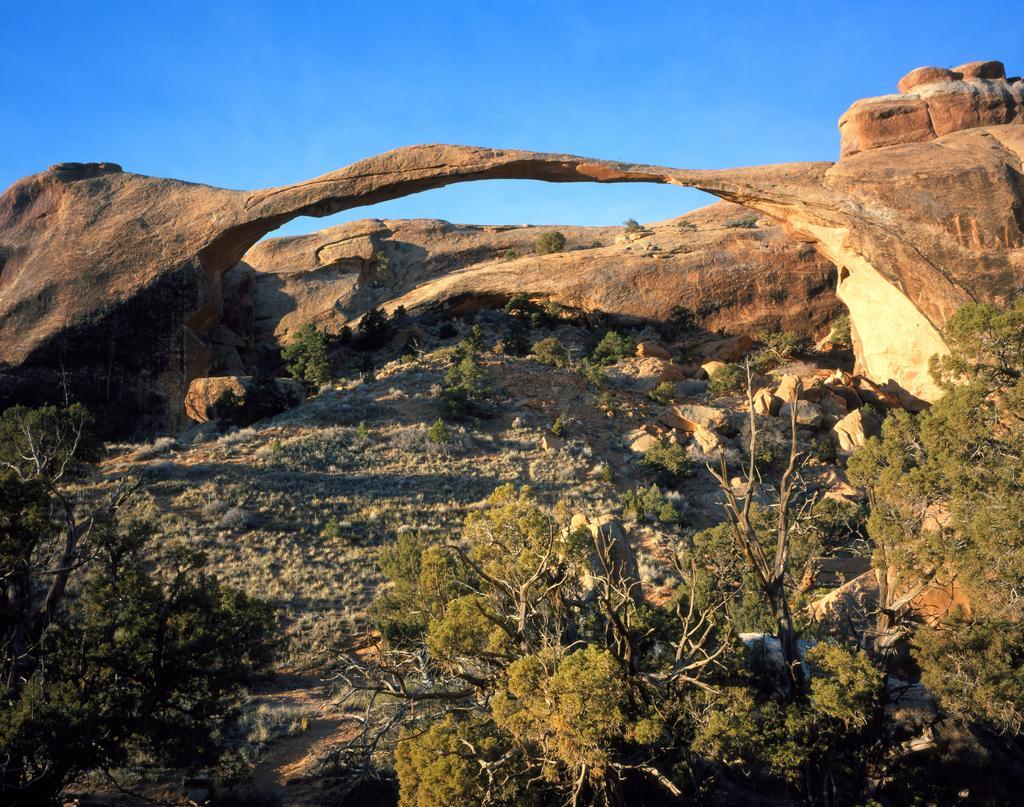Could you give a brief overview of what you see in this image? In this picture we can see few trees and a arch. 